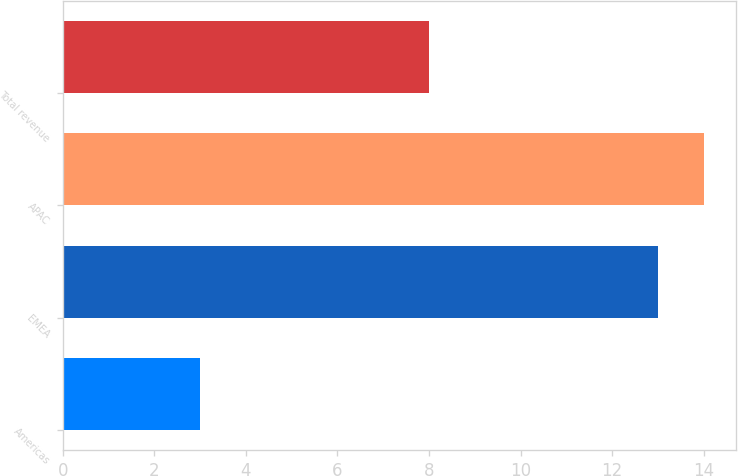Convert chart to OTSL. <chart><loc_0><loc_0><loc_500><loc_500><bar_chart><fcel>Americas<fcel>EMEA<fcel>APAC<fcel>Total revenue<nl><fcel>3<fcel>13<fcel>14<fcel>8<nl></chart> 